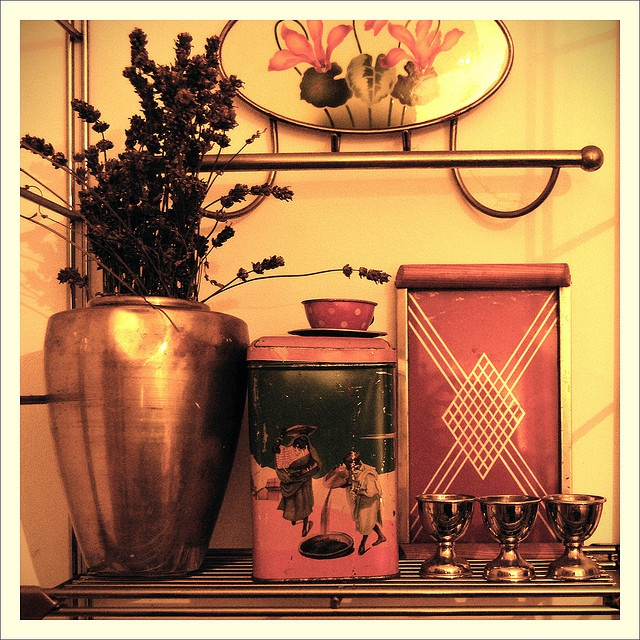Describe the objects in this image and their specific colors. I can see potted plant in gray, black, maroon, brown, and orange tones, vase in gray, maroon, brown, black, and orange tones, cup in gray, black, maroon, brown, and orange tones, wine glass in gray, black, maroon, brown, and orange tones, and wine glass in gray, black, maroon, brown, and orange tones in this image. 